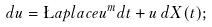<formula> <loc_0><loc_0><loc_500><loc_500>d u = \L a p l a c e u ^ { m } d t + u \, d X ( t ) ;</formula> 